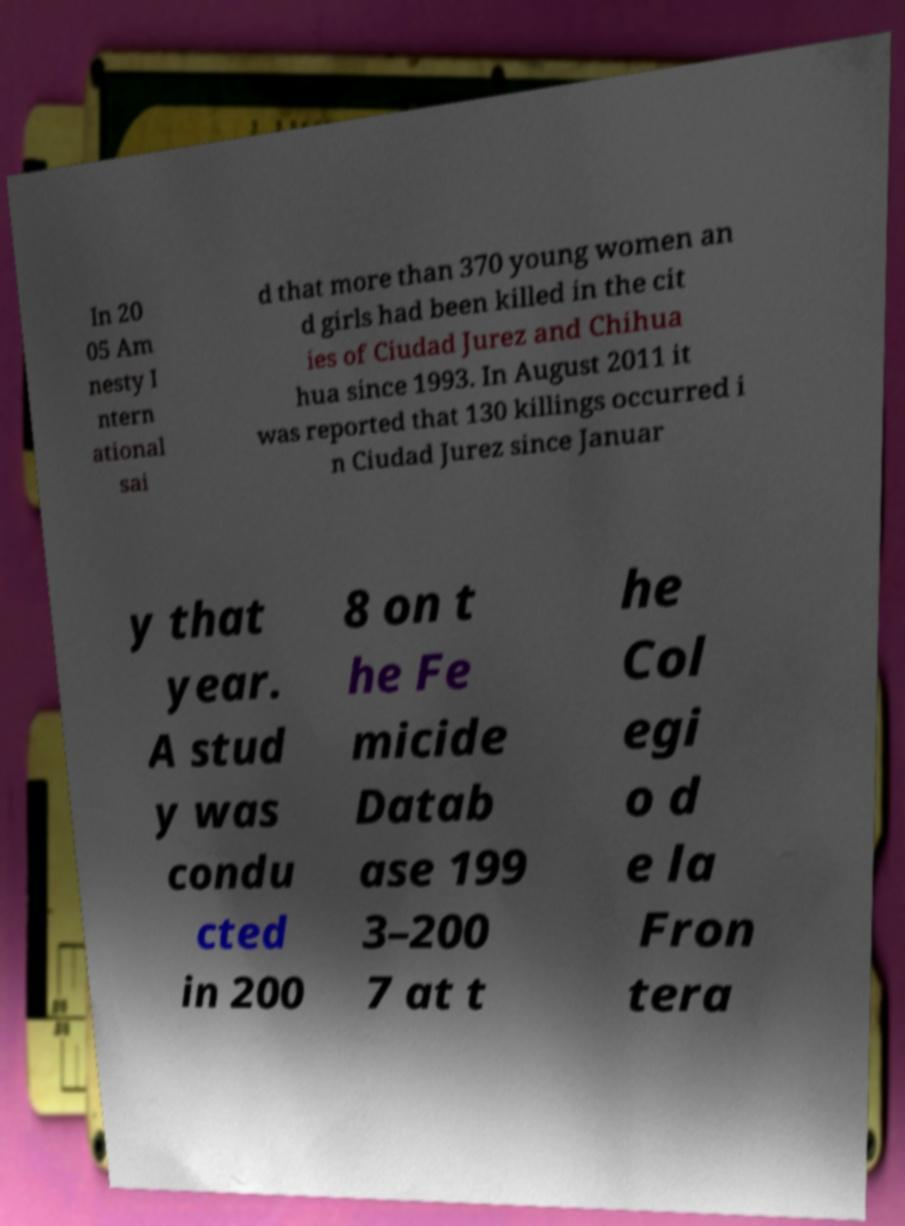There's text embedded in this image that I need extracted. Can you transcribe it verbatim? In 20 05 Am nesty I ntern ational sai d that more than 370 young women an d girls had been killed in the cit ies of Ciudad Jurez and Chihua hua since 1993. In August 2011 it was reported that 130 killings occurred i n Ciudad Jurez since Januar y that year. A stud y was condu cted in 200 8 on t he Fe micide Datab ase 199 3–200 7 at t he Col egi o d e la Fron tera 